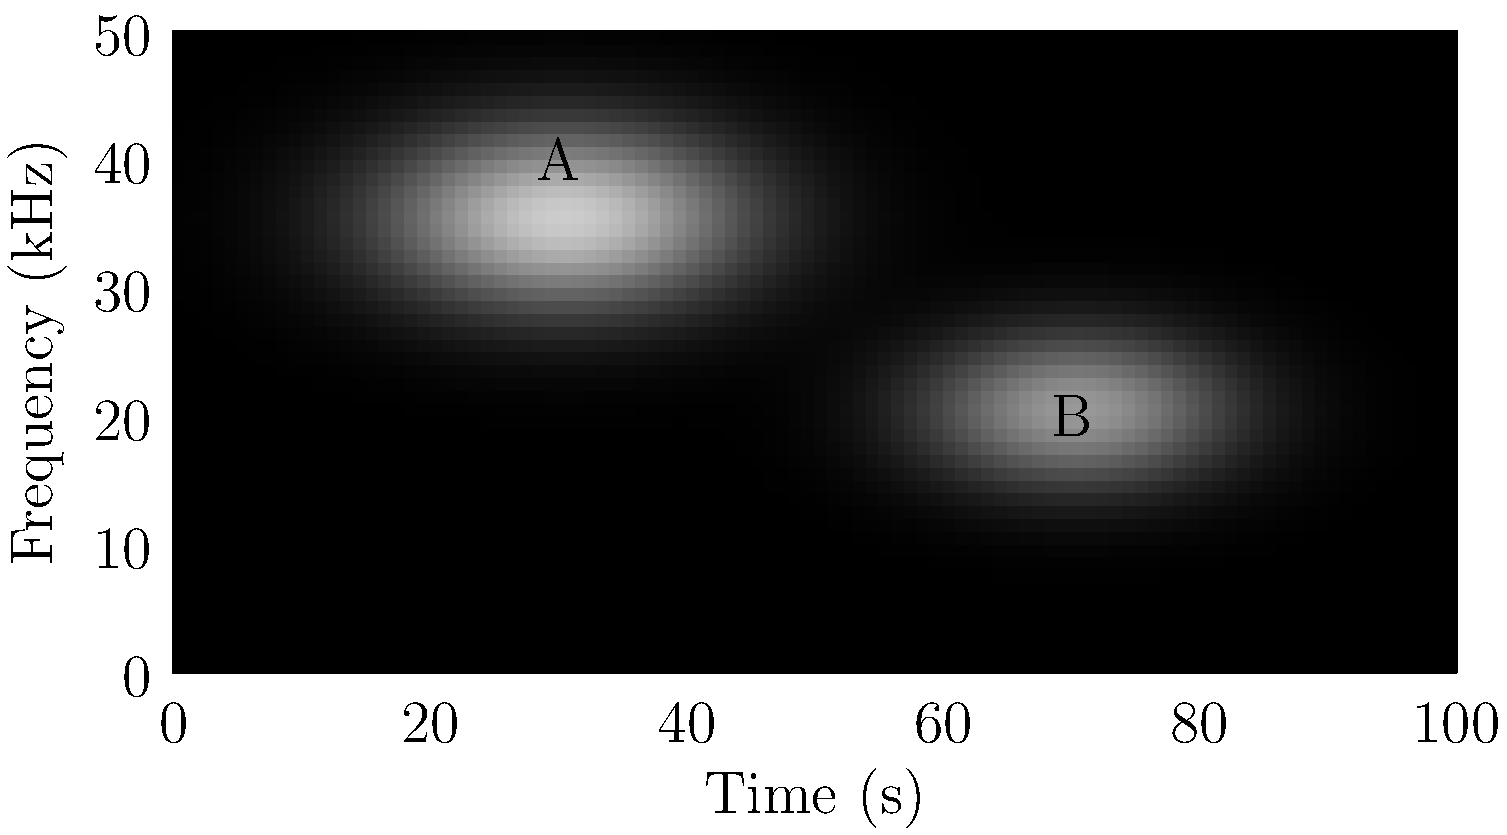Based on the spectrogram image, which of the two distinctive bird calls (labeled A and B) is more likely to belong to the Banded Wren (Thryophilus pleurostictus), an endemic species found in western Mexico known for its high-pitched, rapid trills? To answer this question, we need to analyze the characteristics of the two bird calls shown in the spectrogram:

1. Call A:
   - Located at a higher frequency (around 7 kHz)
   - Shorter duration (about 0.3 seconds)
   - Appears to have a more concentrated energy distribution

2. Call B:
   - Located at a lower frequency (around 4 kHz)
   - Longer duration (about 0.4 seconds)
   - Shows a more spread out energy distribution

3. Characteristics of Banded Wren calls:
   - Known for high-pitched vocalizations
   - Produces rapid trills

4. Comparing the calls to Banded Wren characteristics:
   - Call A is higher-pitched, matching the Banded Wren's known vocalizations
   - Call A appears to have a more rapid, trill-like structure due to its concentrated energy and shorter duration

5. Conclusion:
   Based on the higher pitch and rapid trill-like structure, Call A is more likely to belong to the Banded Wren.
Answer: Call A 